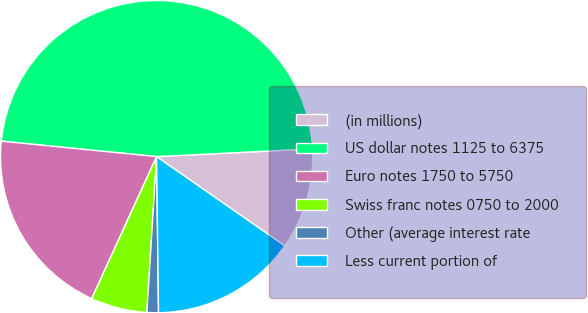Convert chart. <chart><loc_0><loc_0><loc_500><loc_500><pie_chart><fcel>(in millions)<fcel>US dollar notes 1125 to 6375<fcel>Euro notes 1750 to 5750<fcel>Swiss franc notes 0750 to 2000<fcel>Other (average interest rate<fcel>Less current portion of<nl><fcel>10.47%<fcel>47.63%<fcel>19.76%<fcel>5.83%<fcel>1.19%<fcel>15.12%<nl></chart> 